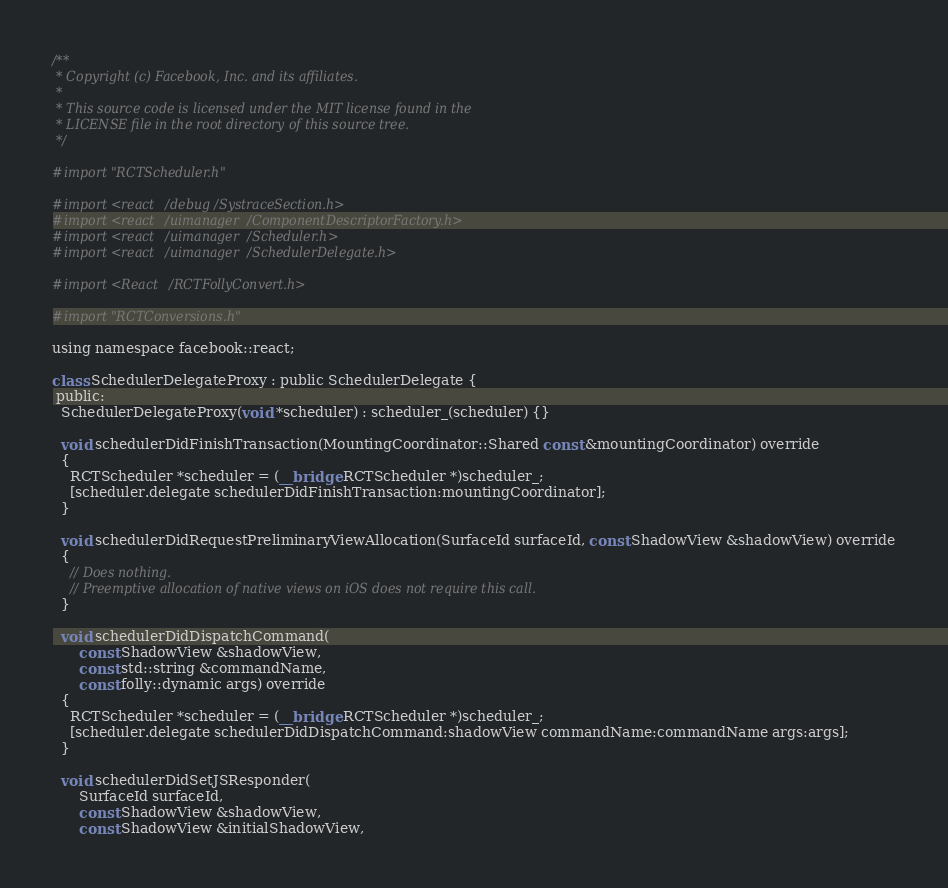Convert code to text. <code><loc_0><loc_0><loc_500><loc_500><_ObjectiveC_>/**
 * Copyright (c) Facebook, Inc. and its affiliates.
 *
 * This source code is licensed under the MIT license found in the
 * LICENSE file in the root directory of this source tree.
 */

#import "RCTScheduler.h"

#import <react/debug/SystraceSection.h>
#import <react/uimanager/ComponentDescriptorFactory.h>
#import <react/uimanager/Scheduler.h>
#import <react/uimanager/SchedulerDelegate.h>

#import <React/RCTFollyConvert.h>

#import "RCTConversions.h"

using namespace facebook::react;

class SchedulerDelegateProxy : public SchedulerDelegate {
 public:
  SchedulerDelegateProxy(void *scheduler) : scheduler_(scheduler) {}

  void schedulerDidFinishTransaction(MountingCoordinator::Shared const &mountingCoordinator) override
  {
    RCTScheduler *scheduler = (__bridge RCTScheduler *)scheduler_;
    [scheduler.delegate schedulerDidFinishTransaction:mountingCoordinator];
  }

  void schedulerDidRequestPreliminaryViewAllocation(SurfaceId surfaceId, const ShadowView &shadowView) override
  {
    // Does nothing.
    // Preemptive allocation of native views on iOS does not require this call.
  }

  void schedulerDidDispatchCommand(
      const ShadowView &shadowView,
      const std::string &commandName,
      const folly::dynamic args) override
  {
    RCTScheduler *scheduler = (__bridge RCTScheduler *)scheduler_;
    [scheduler.delegate schedulerDidDispatchCommand:shadowView commandName:commandName args:args];
  }

  void schedulerDidSetJSResponder(
      SurfaceId surfaceId,
      const ShadowView &shadowView,
      const ShadowView &initialShadowView,</code> 